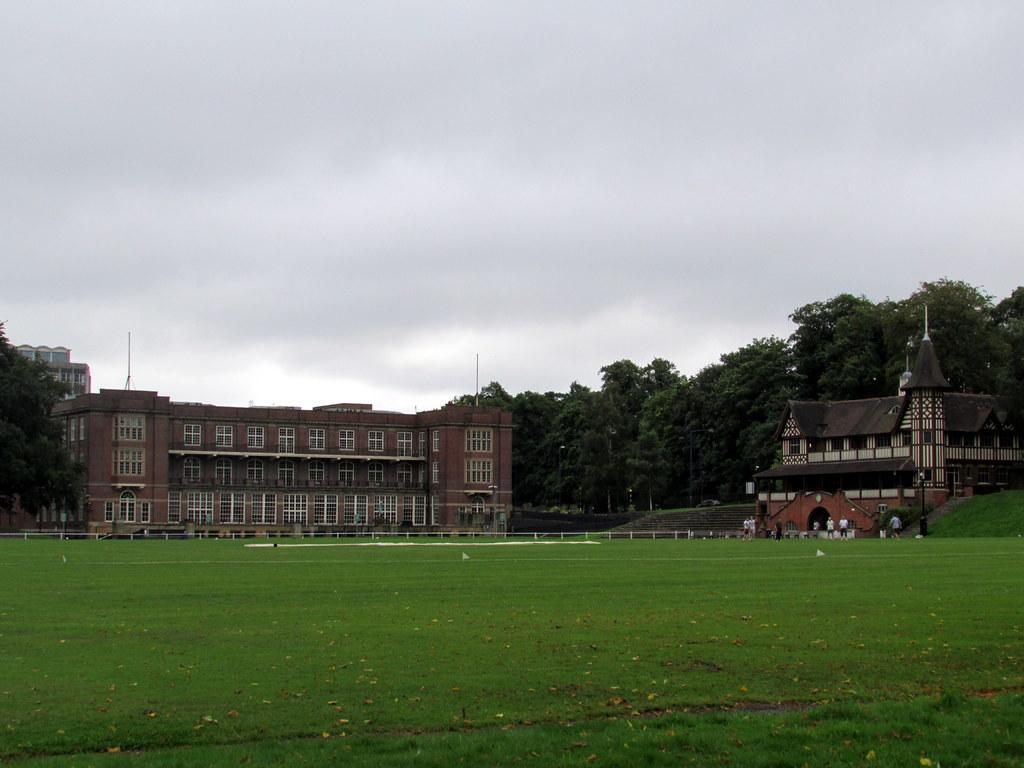Can you describe this image briefly? In this image we can see a building with windows. On the right side we can see a house with roof and windows. we can also see some plants, trees, grass, pole and the sky which looks cloudy. 